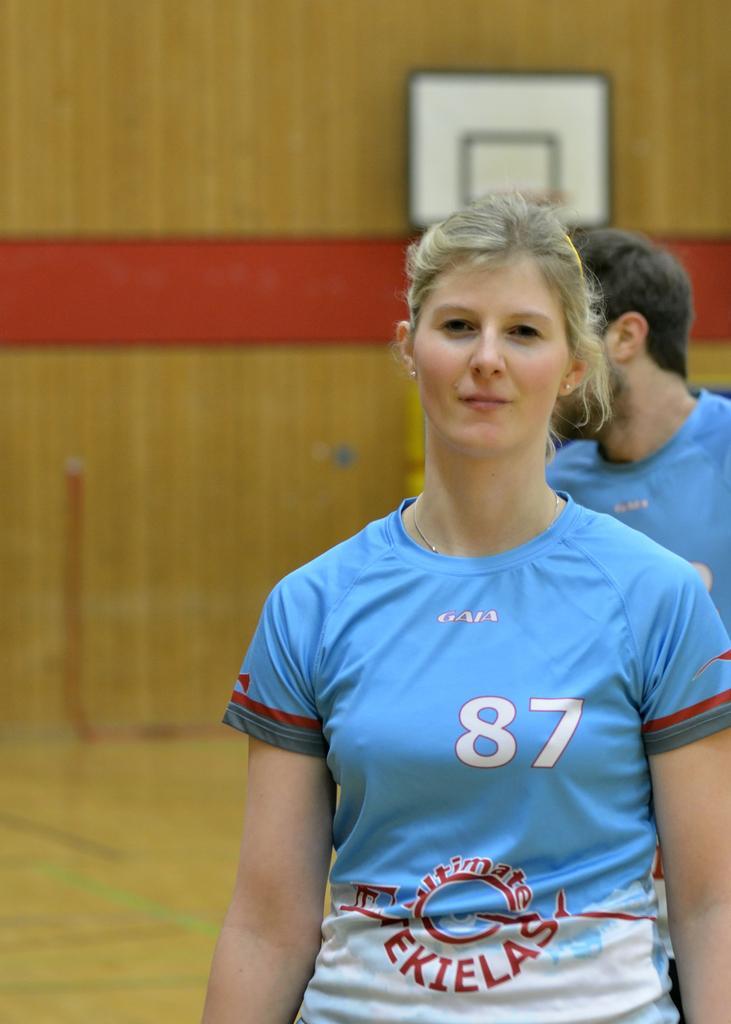Could you give a brief overview of what you see in this image? In the middle of the image a woman is standing and smiling. Behind her there is a person. Behind them there is wall. 